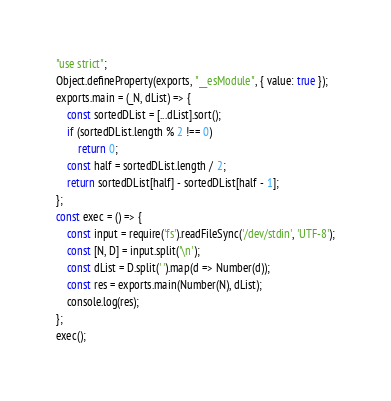<code> <loc_0><loc_0><loc_500><loc_500><_JavaScript_>"use strict";
Object.defineProperty(exports, "__esModule", { value: true });
exports.main = (_N, dList) => {
    const sortedDList = [...dList].sort();
    if (sortedDList.length % 2 !== 0)
        return 0;
    const half = sortedDList.length / 2;
    return sortedDList[half] - sortedDList[half - 1];
};
const exec = () => {
    const input = require('fs').readFileSync('/dev/stdin', 'UTF-8');
    const [N, D] = input.split('\n');
    const dList = D.split(' ').map(d => Number(d));
    const res = exports.main(Number(N), dList);
    console.log(res);
};
exec();
</code> 